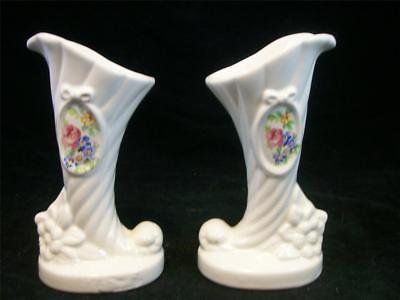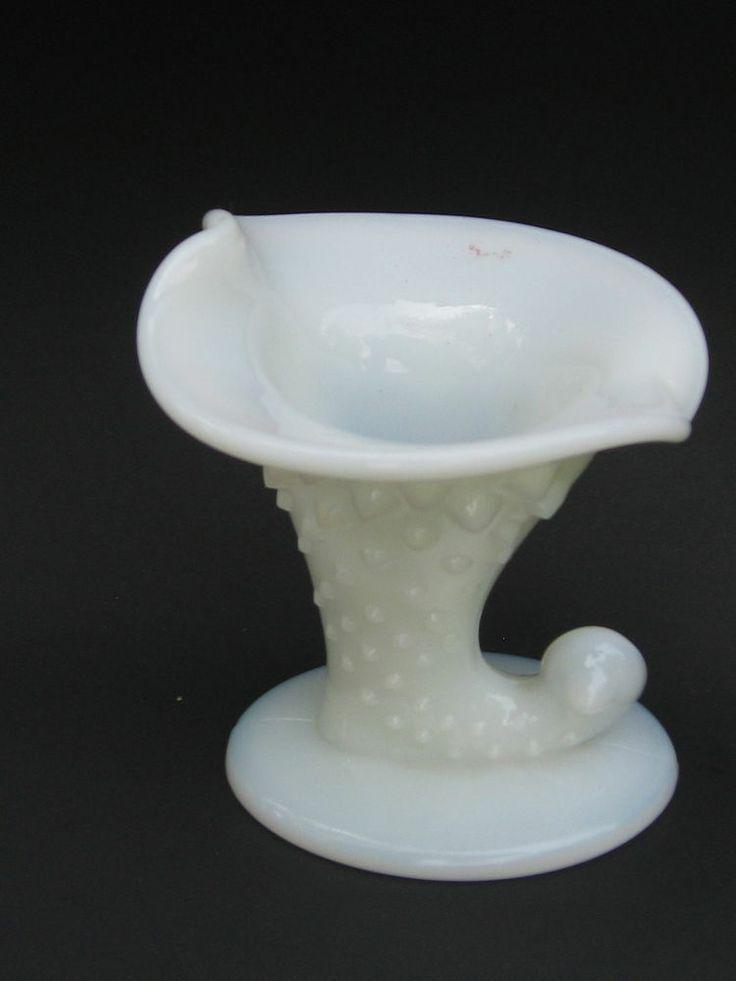The first image is the image on the left, the second image is the image on the right. For the images shown, is this caption "Two vases in one image are a matched set, while a single vase in the second image is solid white on an oval base." true? Answer yes or no. Yes. The first image is the image on the left, the second image is the image on the right. Assess this claim about the two images: "An image shows a matched pair of white vases.". Correct or not? Answer yes or no. Yes. 